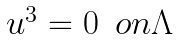<formula> <loc_0><loc_0><loc_500><loc_500>\begin{array} { l l } u ^ { 3 } = 0 & o n \Lambda \end{array}</formula> 